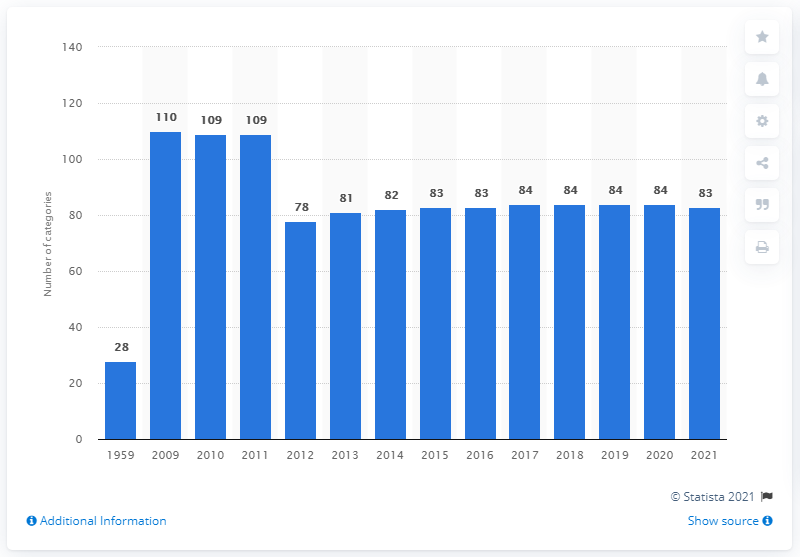List a handful of essential elements in this visual. The Grammy Awards will be presented in 83 categories in 2021. When the Grammy Awards were first introduced in 1959, a total of 28 categories were available for nomination. The Grammy Awards were introduced in 1959. 